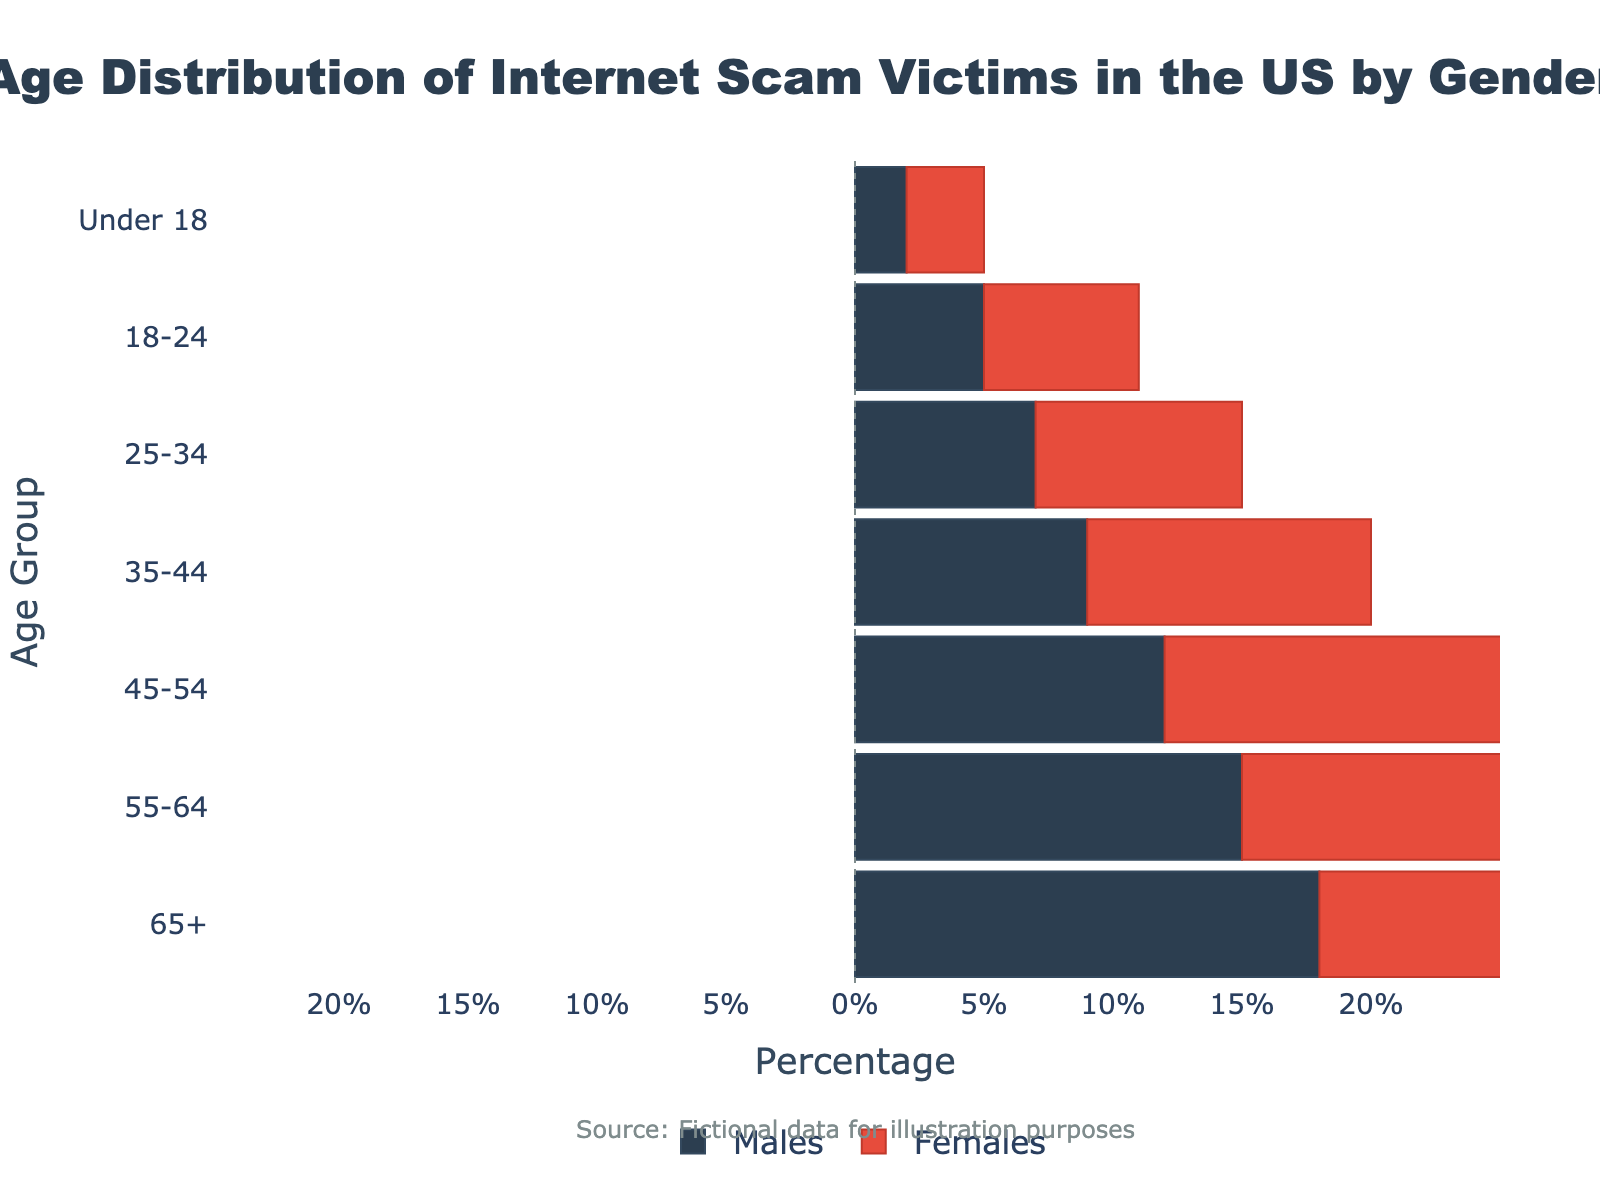What is the title of the plot? The title is located at the top of the plot, centered and prominently displayed. It reads: "Age Distribution of Internet Scam Victims in the US by Gender."
Answer: Age Distribution of Internet Scam Victims in the US by Gender How many age groups are represented in the figure? The age groups are represented by horizontal bars and are labeled on the y-axis. Counting these labels gives us a total of 7 age groups.
Answer: 7 Which age group has the highest percentage of male scam victims? By examining the length of the blue bars (representing males), the age group with the bar extending the farthest to the left (most negative value) is "65+."
Answer: 65+ By how many percentage points do female scam victims in the "55-64" age group outnumber male scam victims? In the "55-64" age group, females are represented by a bar at +19% and males by a bar at -15%. The difference is calculated by 19 - 15 = 34%.
Answer: 34% What is the total percentage of internet scam victims for the age group "18-24"? The total percentage is the sum of male and female victims. Males have -5% and females have +6%. Adding these together: -5 + 6 = 1%.
Answer: 1% Which gender has more victims in the "Under 18" age group? The bar representing females extends to +3%, while the bar representing males extends to -2%. Since 3% is greater than 2%, females have more victims.
Answer: Females How does the percentage of male and female victims differ in the "45-54" age group? Males in this age group are represented by a bar at -12%, and females by a bar at +14%. The difference is 14 - (-12) = 26%.
Answer: 26% Compare the percentage of male victims in the "25-34" age group with the "35-44" age group. In the "25-34" age group, males are represented by -7%, and in the "35-44" age group, they are at -9%. -7% is greater than -9%, so there are more male victims in the "25-34" age group.
Answer: "25-34" What is the overall trend for internet scam victims as age increases, regardless of gender? Observing the length of the bars for both males (left side) and females (right side), both percentages increase with age. This shows an overall increasing trend of scam victims as age increases.
Answer: Increasing Which age group has nearly equal percentages of male and female scam victims? The "Under 18" age group has percentages where males are at -2% and females are at 3%. The difference is small, indicating nearly equal distribution between genders in this age group.
Answer: Under 18 